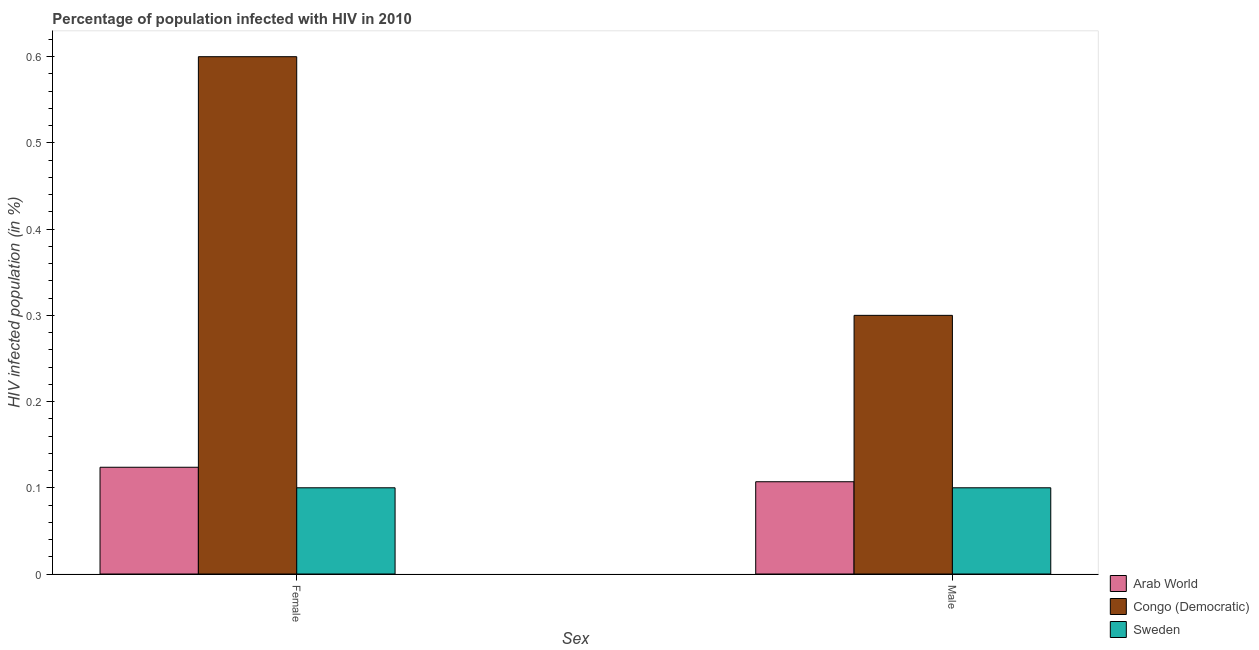How many different coloured bars are there?
Keep it short and to the point. 3. Are the number of bars per tick equal to the number of legend labels?
Give a very brief answer. Yes. Are the number of bars on each tick of the X-axis equal?
Offer a terse response. Yes. How many bars are there on the 2nd tick from the left?
Ensure brevity in your answer.  3. How many bars are there on the 1st tick from the right?
Offer a terse response. 3. What is the percentage of females who are infected with hiv in Congo (Democratic)?
Give a very brief answer. 0.6. In which country was the percentage of males who are infected with hiv maximum?
Your response must be concise. Congo (Democratic). In which country was the percentage of males who are infected with hiv minimum?
Your answer should be compact. Sweden. What is the total percentage of females who are infected with hiv in the graph?
Offer a very short reply. 0.82. What is the difference between the percentage of females who are infected with hiv in Congo (Democratic) and that in Sweden?
Give a very brief answer. 0.5. What is the difference between the percentage of males who are infected with hiv in Congo (Democratic) and the percentage of females who are infected with hiv in Arab World?
Make the answer very short. 0.18. What is the average percentage of females who are infected with hiv per country?
Your answer should be compact. 0.27. In how many countries, is the percentage of females who are infected with hiv greater than 0.58 %?
Your response must be concise. 1. What is the ratio of the percentage of males who are infected with hiv in Sweden to that in Arab World?
Make the answer very short. 0.93. Is the percentage of males who are infected with hiv in Arab World less than that in Sweden?
Ensure brevity in your answer.  No. What does the 1st bar from the left in Female represents?
Your answer should be compact. Arab World. What does the 3rd bar from the right in Male represents?
Ensure brevity in your answer.  Arab World. How many bars are there?
Your answer should be very brief. 6. Does the graph contain grids?
Keep it short and to the point. No. What is the title of the graph?
Make the answer very short. Percentage of population infected with HIV in 2010. What is the label or title of the X-axis?
Make the answer very short. Sex. What is the label or title of the Y-axis?
Keep it short and to the point. HIV infected population (in %). What is the HIV infected population (in %) in Arab World in Female?
Your response must be concise. 0.12. What is the HIV infected population (in %) in Congo (Democratic) in Female?
Offer a very short reply. 0.6. What is the HIV infected population (in %) of Arab World in Male?
Your answer should be compact. 0.11. What is the HIV infected population (in %) in Sweden in Male?
Your answer should be compact. 0.1. Across all Sex, what is the maximum HIV infected population (in %) in Arab World?
Keep it short and to the point. 0.12. Across all Sex, what is the maximum HIV infected population (in %) of Congo (Democratic)?
Ensure brevity in your answer.  0.6. Across all Sex, what is the minimum HIV infected population (in %) of Arab World?
Provide a succinct answer. 0.11. Across all Sex, what is the minimum HIV infected population (in %) in Congo (Democratic)?
Give a very brief answer. 0.3. What is the total HIV infected population (in %) of Arab World in the graph?
Provide a short and direct response. 0.23. What is the total HIV infected population (in %) of Congo (Democratic) in the graph?
Give a very brief answer. 0.9. What is the total HIV infected population (in %) in Sweden in the graph?
Your response must be concise. 0.2. What is the difference between the HIV infected population (in %) of Arab World in Female and that in Male?
Keep it short and to the point. 0.02. What is the difference between the HIV infected population (in %) in Sweden in Female and that in Male?
Provide a succinct answer. 0. What is the difference between the HIV infected population (in %) of Arab World in Female and the HIV infected population (in %) of Congo (Democratic) in Male?
Offer a very short reply. -0.18. What is the difference between the HIV infected population (in %) of Arab World in Female and the HIV infected population (in %) of Sweden in Male?
Provide a succinct answer. 0.02. What is the average HIV infected population (in %) of Arab World per Sex?
Offer a very short reply. 0.12. What is the average HIV infected population (in %) in Congo (Democratic) per Sex?
Offer a terse response. 0.45. What is the average HIV infected population (in %) in Sweden per Sex?
Give a very brief answer. 0.1. What is the difference between the HIV infected population (in %) of Arab World and HIV infected population (in %) of Congo (Democratic) in Female?
Your answer should be very brief. -0.48. What is the difference between the HIV infected population (in %) of Arab World and HIV infected population (in %) of Sweden in Female?
Offer a terse response. 0.02. What is the difference between the HIV infected population (in %) in Arab World and HIV infected population (in %) in Congo (Democratic) in Male?
Provide a short and direct response. -0.19. What is the difference between the HIV infected population (in %) in Arab World and HIV infected population (in %) in Sweden in Male?
Your response must be concise. 0.01. What is the difference between the HIV infected population (in %) in Congo (Democratic) and HIV infected population (in %) in Sweden in Male?
Provide a succinct answer. 0.2. What is the ratio of the HIV infected population (in %) in Arab World in Female to that in Male?
Give a very brief answer. 1.16. What is the ratio of the HIV infected population (in %) of Sweden in Female to that in Male?
Provide a succinct answer. 1. What is the difference between the highest and the second highest HIV infected population (in %) in Arab World?
Ensure brevity in your answer.  0.02. What is the difference between the highest and the second highest HIV infected population (in %) of Congo (Democratic)?
Provide a succinct answer. 0.3. What is the difference between the highest and the second highest HIV infected population (in %) of Sweden?
Keep it short and to the point. 0. What is the difference between the highest and the lowest HIV infected population (in %) in Arab World?
Make the answer very short. 0.02. What is the difference between the highest and the lowest HIV infected population (in %) in Congo (Democratic)?
Give a very brief answer. 0.3. 